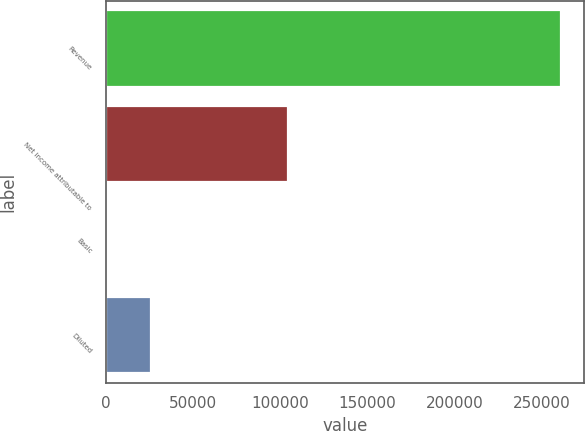Convert chart. <chart><loc_0><loc_0><loc_500><loc_500><bar_chart><fcel>Revenue<fcel>Net income attributable to<fcel>Basic<fcel>Diluted<nl><fcel>261305<fcel>104522<fcel>0.28<fcel>26130.8<nl></chart> 